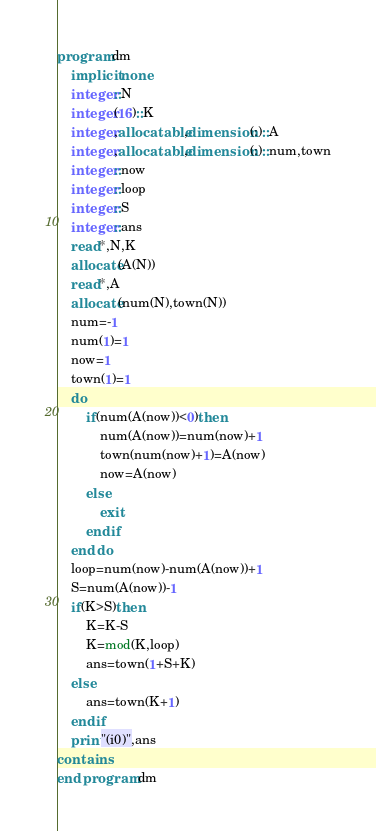Convert code to text. <code><loc_0><loc_0><loc_500><loc_500><_FORTRAN_>program dm
    implicit none
    integer::N
    integer(16)::K
    integer,allocatable,dimension(:)::A
    integer,allocatable,dimension(:)::num,town
    integer::now
    integer::loop
    integer::S
    integer::ans
    read*,N,K
    allocate(A(N))
    read*,A
    allocate(num(N),town(N))
    num=-1
    num(1)=1
    now=1
    town(1)=1
    do
        if(num(A(now))<0)then
            num(A(now))=num(now)+1
            town(num(now)+1)=A(now)
            now=A(now)
        else
            exit
        endif
    end do
    loop=num(now)-num(A(now))+1
    S=num(A(now))-1
    if(K>S)then
        K=K-S
        K=mod(K,loop)
        ans=town(1+S+K)
    else
        ans=town(K+1)
    endif
    print"(i0)",ans
contains
end program dm</code> 